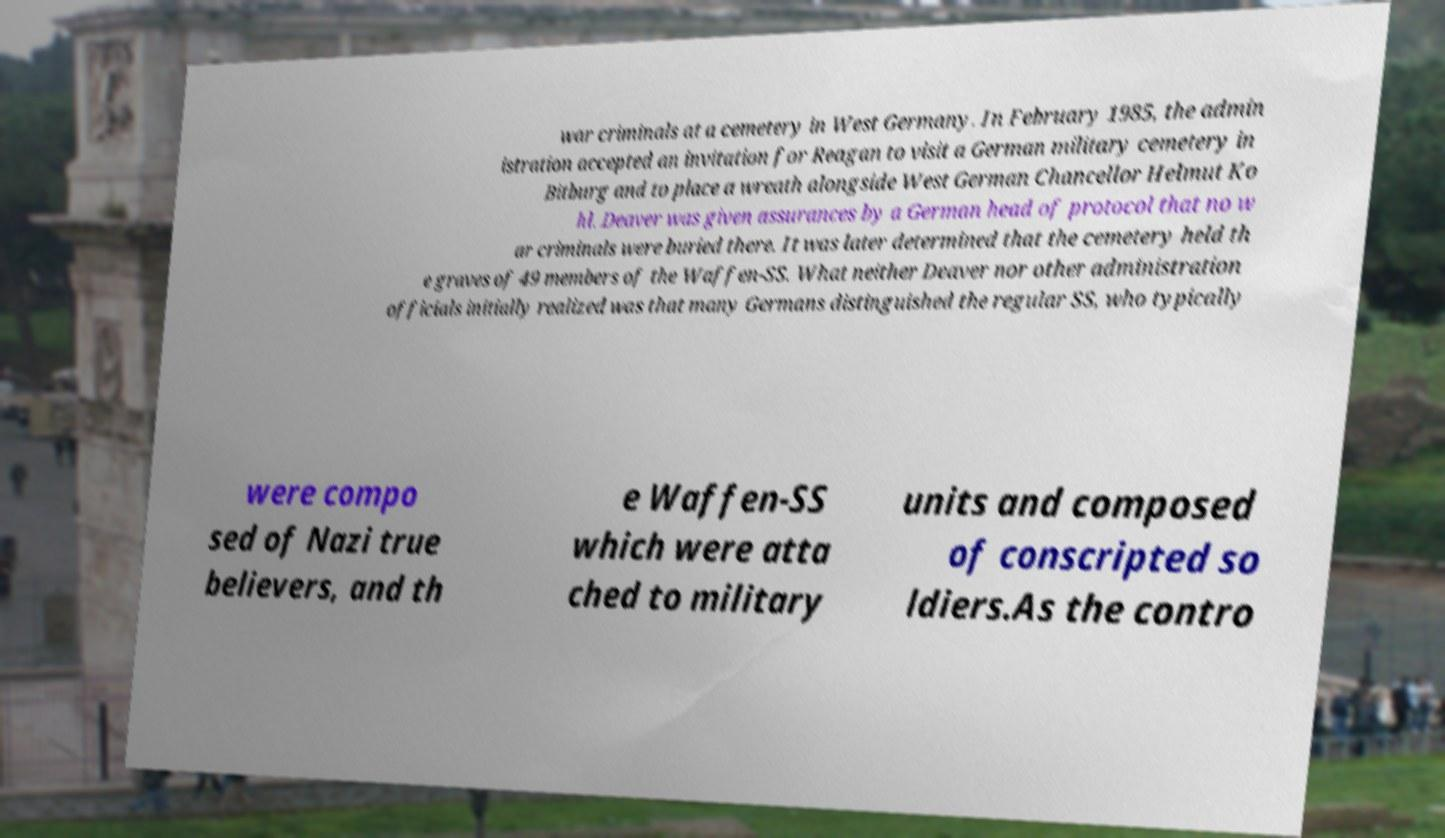What messages or text are displayed in this image? I need them in a readable, typed format. war criminals at a cemetery in West Germany. In February 1985, the admin istration accepted an invitation for Reagan to visit a German military cemetery in Bitburg and to place a wreath alongside West German Chancellor Helmut Ko hl. Deaver was given assurances by a German head of protocol that no w ar criminals were buried there. It was later determined that the cemetery held th e graves of 49 members of the Waffen-SS. What neither Deaver nor other administration officials initially realized was that many Germans distinguished the regular SS, who typically were compo sed of Nazi true believers, and th e Waffen-SS which were atta ched to military units and composed of conscripted so ldiers.As the contro 